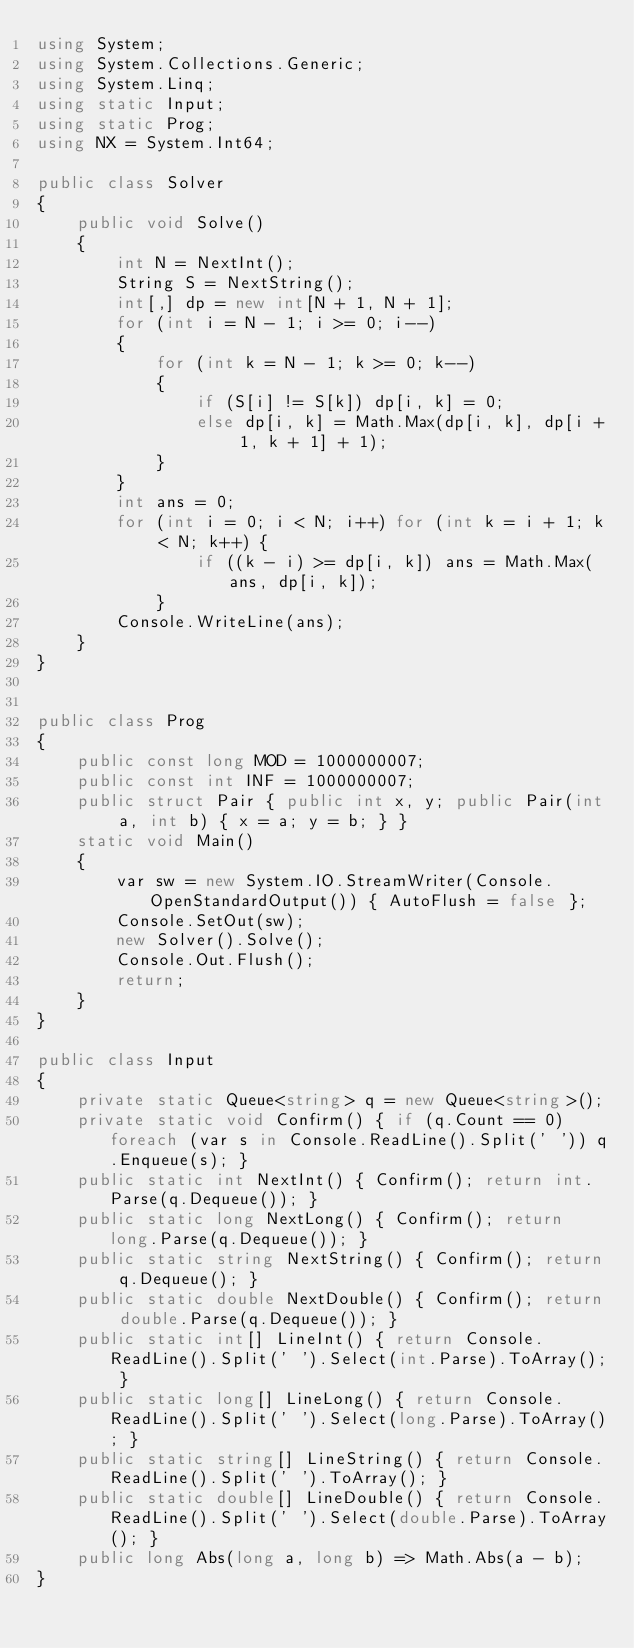<code> <loc_0><loc_0><loc_500><loc_500><_C#_>using System;
using System.Collections.Generic;
using System.Linq;
using static Input;
using static Prog;
using NX = System.Int64;

public class Solver
{
    public void Solve()
    {
        int N = NextInt();
        String S = NextString();
        int[,] dp = new int[N + 1, N + 1];
        for (int i = N - 1; i >= 0; i--)
        {
            for (int k = N - 1; k >= 0; k--)
            {
                if (S[i] != S[k]) dp[i, k] = 0;
                else dp[i, k] = Math.Max(dp[i, k], dp[i + 1, k + 1] + 1);
            }
        }
        int ans = 0;
        for (int i = 0; i < N; i++) for (int k = i + 1; k < N; k++) {
                if ((k - i) >= dp[i, k]) ans = Math.Max(ans, dp[i, k]);
            }
        Console.WriteLine(ans);
    }
}


public class Prog
{
    public const long MOD = 1000000007;
    public const int INF = 1000000007;
    public struct Pair { public int x, y; public Pair(int a, int b) { x = a; y = b; } }
    static void Main()
    {
        var sw = new System.IO.StreamWriter(Console.OpenStandardOutput()) { AutoFlush = false };
        Console.SetOut(sw);
        new Solver().Solve();
        Console.Out.Flush();
        return;
    }
}

public class Input
{
    private static Queue<string> q = new Queue<string>();
    private static void Confirm() { if (q.Count == 0) foreach (var s in Console.ReadLine().Split(' ')) q.Enqueue(s); }
    public static int NextInt() { Confirm(); return int.Parse(q.Dequeue()); }
    public static long NextLong() { Confirm(); return long.Parse(q.Dequeue()); }
    public static string NextString() { Confirm(); return q.Dequeue(); }
    public static double NextDouble() { Confirm(); return double.Parse(q.Dequeue()); }
    public static int[] LineInt() { return Console.ReadLine().Split(' ').Select(int.Parse).ToArray(); }
    public static long[] LineLong() { return Console.ReadLine().Split(' ').Select(long.Parse).ToArray(); }
    public static string[] LineString() { return Console.ReadLine().Split(' ').ToArray(); }
    public static double[] LineDouble() { return Console.ReadLine().Split(' ').Select(double.Parse).ToArray(); }
    public long Abs(long a, long b) => Math.Abs(a - b);
}
</code> 